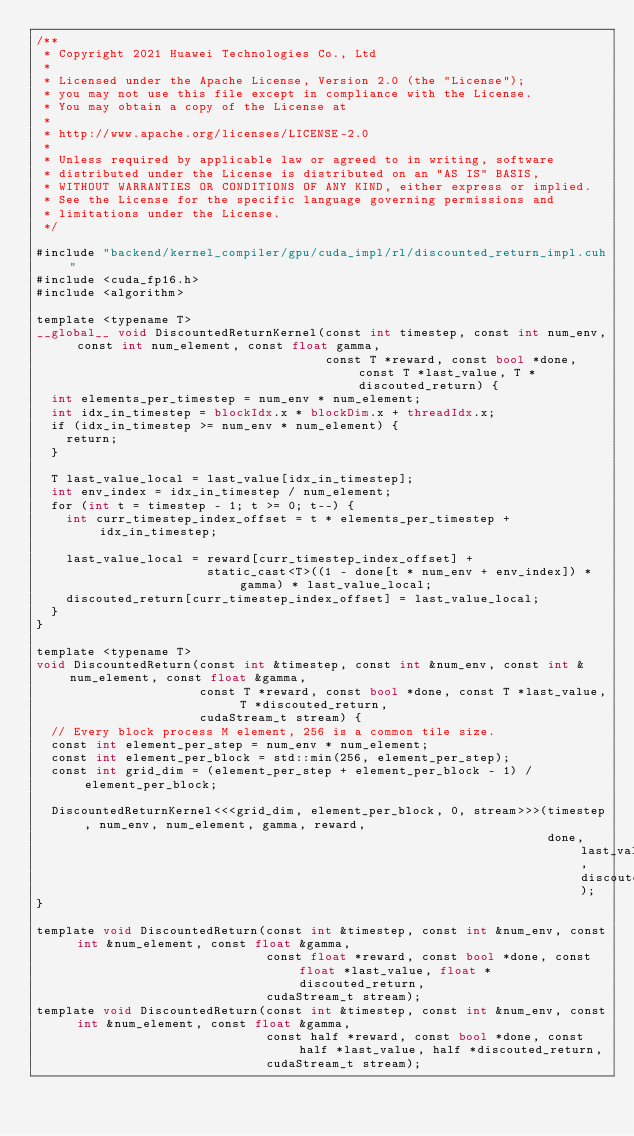<code> <loc_0><loc_0><loc_500><loc_500><_Cuda_>/**
 * Copyright 2021 Huawei Technologies Co., Ltd
 *
 * Licensed under the Apache License, Version 2.0 (the "License");
 * you may not use this file except in compliance with the License.
 * You may obtain a copy of the License at
 *
 * http://www.apache.org/licenses/LICENSE-2.0
 *
 * Unless required by applicable law or agreed to in writing, software
 * distributed under the License is distributed on an "AS IS" BASIS,
 * WITHOUT WARRANTIES OR CONDITIONS OF ANY KIND, either express or implied.
 * See the License for the specific language governing permissions and
 * limitations under the License.
 */

#include "backend/kernel_compiler/gpu/cuda_impl/rl/discounted_return_impl.cuh"
#include <cuda_fp16.h>
#include <algorithm>

template <typename T>
__global__ void DiscountedReturnKernel(const int timestep, const int num_env, const int num_element, const float gamma,
                                       const T *reward, const bool *done, const T *last_value, T *discouted_return) {
  int elements_per_timestep = num_env * num_element;
  int idx_in_timestep = blockIdx.x * blockDim.x + threadIdx.x;
  if (idx_in_timestep >= num_env * num_element) {
    return;
  }

  T last_value_local = last_value[idx_in_timestep];
  int env_index = idx_in_timestep / num_element;
  for (int t = timestep - 1; t >= 0; t--) {
    int curr_timestep_index_offset = t * elements_per_timestep + idx_in_timestep;

    last_value_local = reward[curr_timestep_index_offset] +
                       static_cast<T>((1 - done[t * num_env + env_index]) * gamma) * last_value_local;
    discouted_return[curr_timestep_index_offset] = last_value_local;
  }
}

template <typename T>
void DiscountedReturn(const int &timestep, const int &num_env, const int &num_element, const float &gamma,
                      const T *reward, const bool *done, const T *last_value, T *discouted_return,
                      cudaStream_t stream) {
  // Every block process M element, 256 is a common tile size.
  const int element_per_step = num_env * num_element;
  const int element_per_block = std::min(256, element_per_step);
  const int grid_dim = (element_per_step + element_per_block - 1) / element_per_block;

  DiscountedReturnKernel<<<grid_dim, element_per_block, 0, stream>>>(timestep, num_env, num_element, gamma, reward,
                                                                     done, last_value, discouted_return);
}

template void DiscountedReturn(const int &timestep, const int &num_env, const int &num_element, const float &gamma,
                               const float *reward, const bool *done, const float *last_value, float *discouted_return,
                               cudaStream_t stream);
template void DiscountedReturn(const int &timestep, const int &num_env, const int &num_element, const float &gamma,
                               const half *reward, const bool *done, const half *last_value, half *discouted_return,
                               cudaStream_t stream);
</code> 